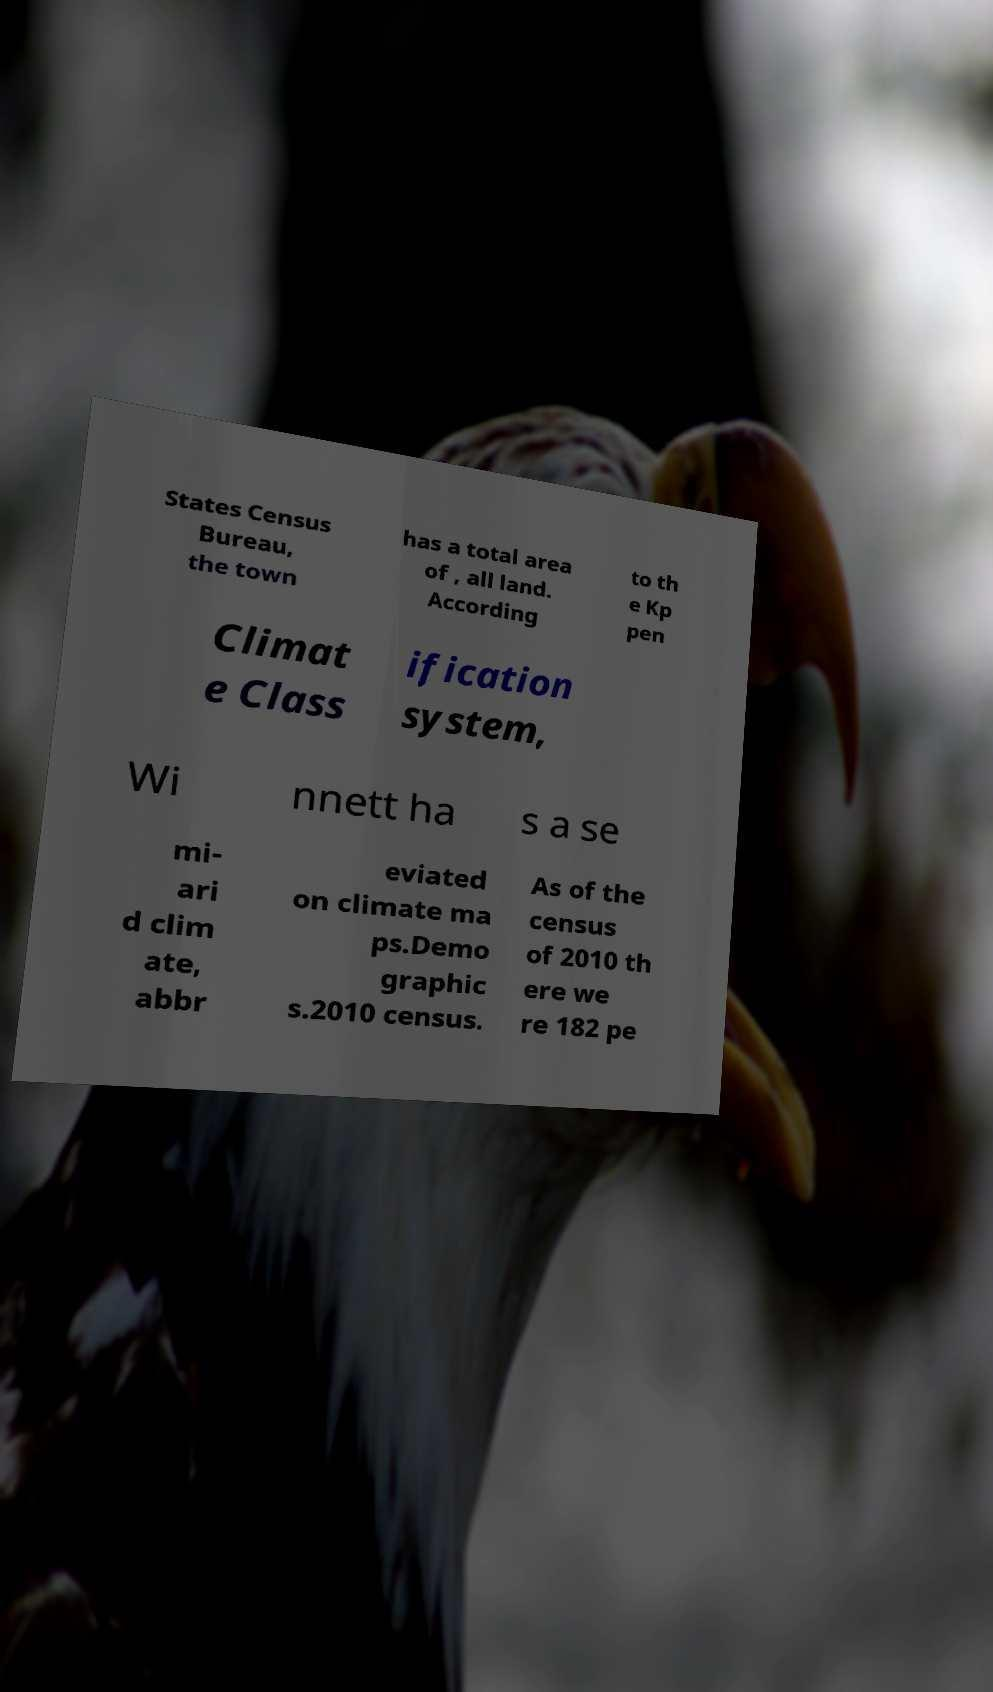What messages or text are displayed in this image? I need them in a readable, typed format. States Census Bureau, the town has a total area of , all land. According to th e Kp pen Climat e Class ification system, Wi nnett ha s a se mi- ari d clim ate, abbr eviated on climate ma ps.Demo graphic s.2010 census. As of the census of 2010 th ere we re 182 pe 